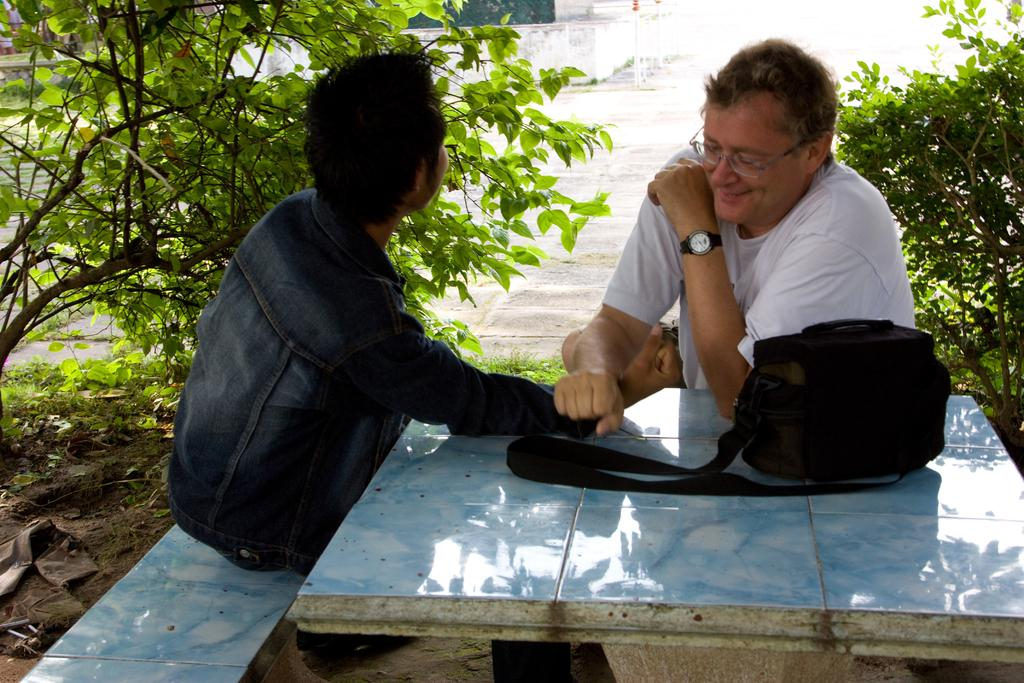What can be seen in the background of the image? There are plants in the background of the image. How many people are sitting in the image? There are two men sitting in the image. What is on the table in the image? There is a black color bag on the table in the image. Can you describe the appearance of one of the men? One man is wearing spectacles. What accessory is visible on the other man? One man is wearing a watch. What type of loaf is being sliced by the men in the image? There is no loaf present in the image; the men are not slicing anything. What color is the coal in the image? There is no coal present in the image. 